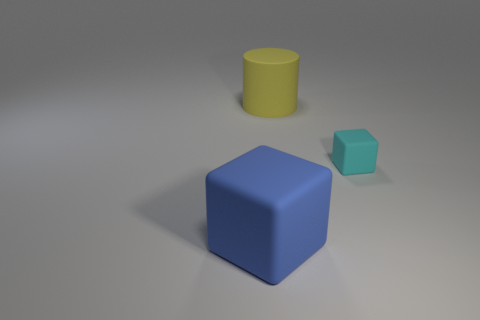The yellow cylinder has what size?
Your answer should be very brief. Large. There is a large yellow matte thing; is it the same shape as the large rubber thing that is in front of the big matte cylinder?
Give a very brief answer. No. There is a cube that is the same material as the large blue object; what color is it?
Offer a very short reply. Cyan. There is a block that is in front of the small thing; what is its size?
Keep it short and to the point. Large. Is the number of tiny matte blocks behind the large rubber cube less than the number of cubes?
Your answer should be very brief. Yes. Is there any other thing that has the same shape as the yellow rubber object?
Your answer should be very brief. No. Are there fewer small cyan rubber balls than cubes?
Your response must be concise. Yes. There is a rubber cube that is to the right of the object behind the small cyan matte thing; what color is it?
Keep it short and to the point. Cyan. The cube that is on the left side of the rubber cube that is right of the big rubber object in front of the small object is made of what material?
Make the answer very short. Rubber. Do the object that is in front of the cyan rubber thing and the yellow cylinder have the same size?
Your response must be concise. Yes. 